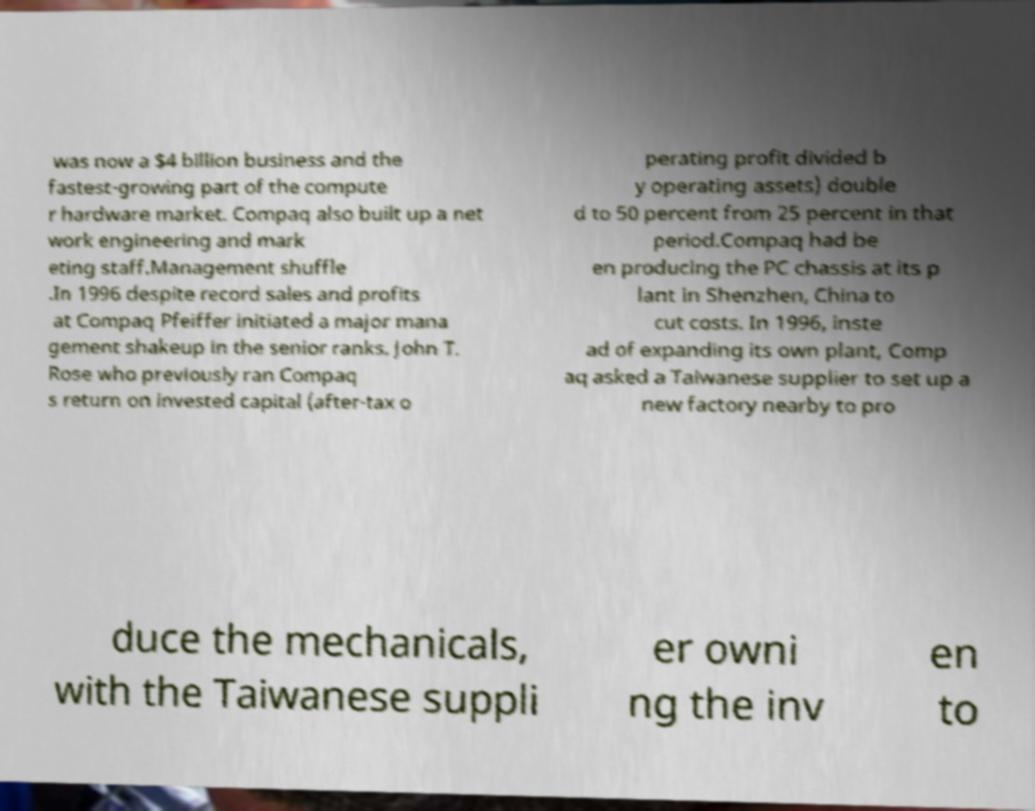There's text embedded in this image that I need extracted. Can you transcribe it verbatim? was now a $4 billion business and the fastest-growing part of the compute r hardware market. Compaq also built up a net work engineering and mark eting staff.Management shuffle .In 1996 despite record sales and profits at Compaq Pfeiffer initiated a major mana gement shakeup in the senior ranks. John T. Rose who previously ran Compaq s return on invested capital (after-tax o perating profit divided b y operating assets) double d to 50 percent from 25 percent in that period.Compaq had be en producing the PC chassis at its p lant in Shenzhen, China to cut costs. In 1996, inste ad of expanding its own plant, Comp aq asked a Taiwanese supplier to set up a new factory nearby to pro duce the mechanicals, with the Taiwanese suppli er owni ng the inv en to 